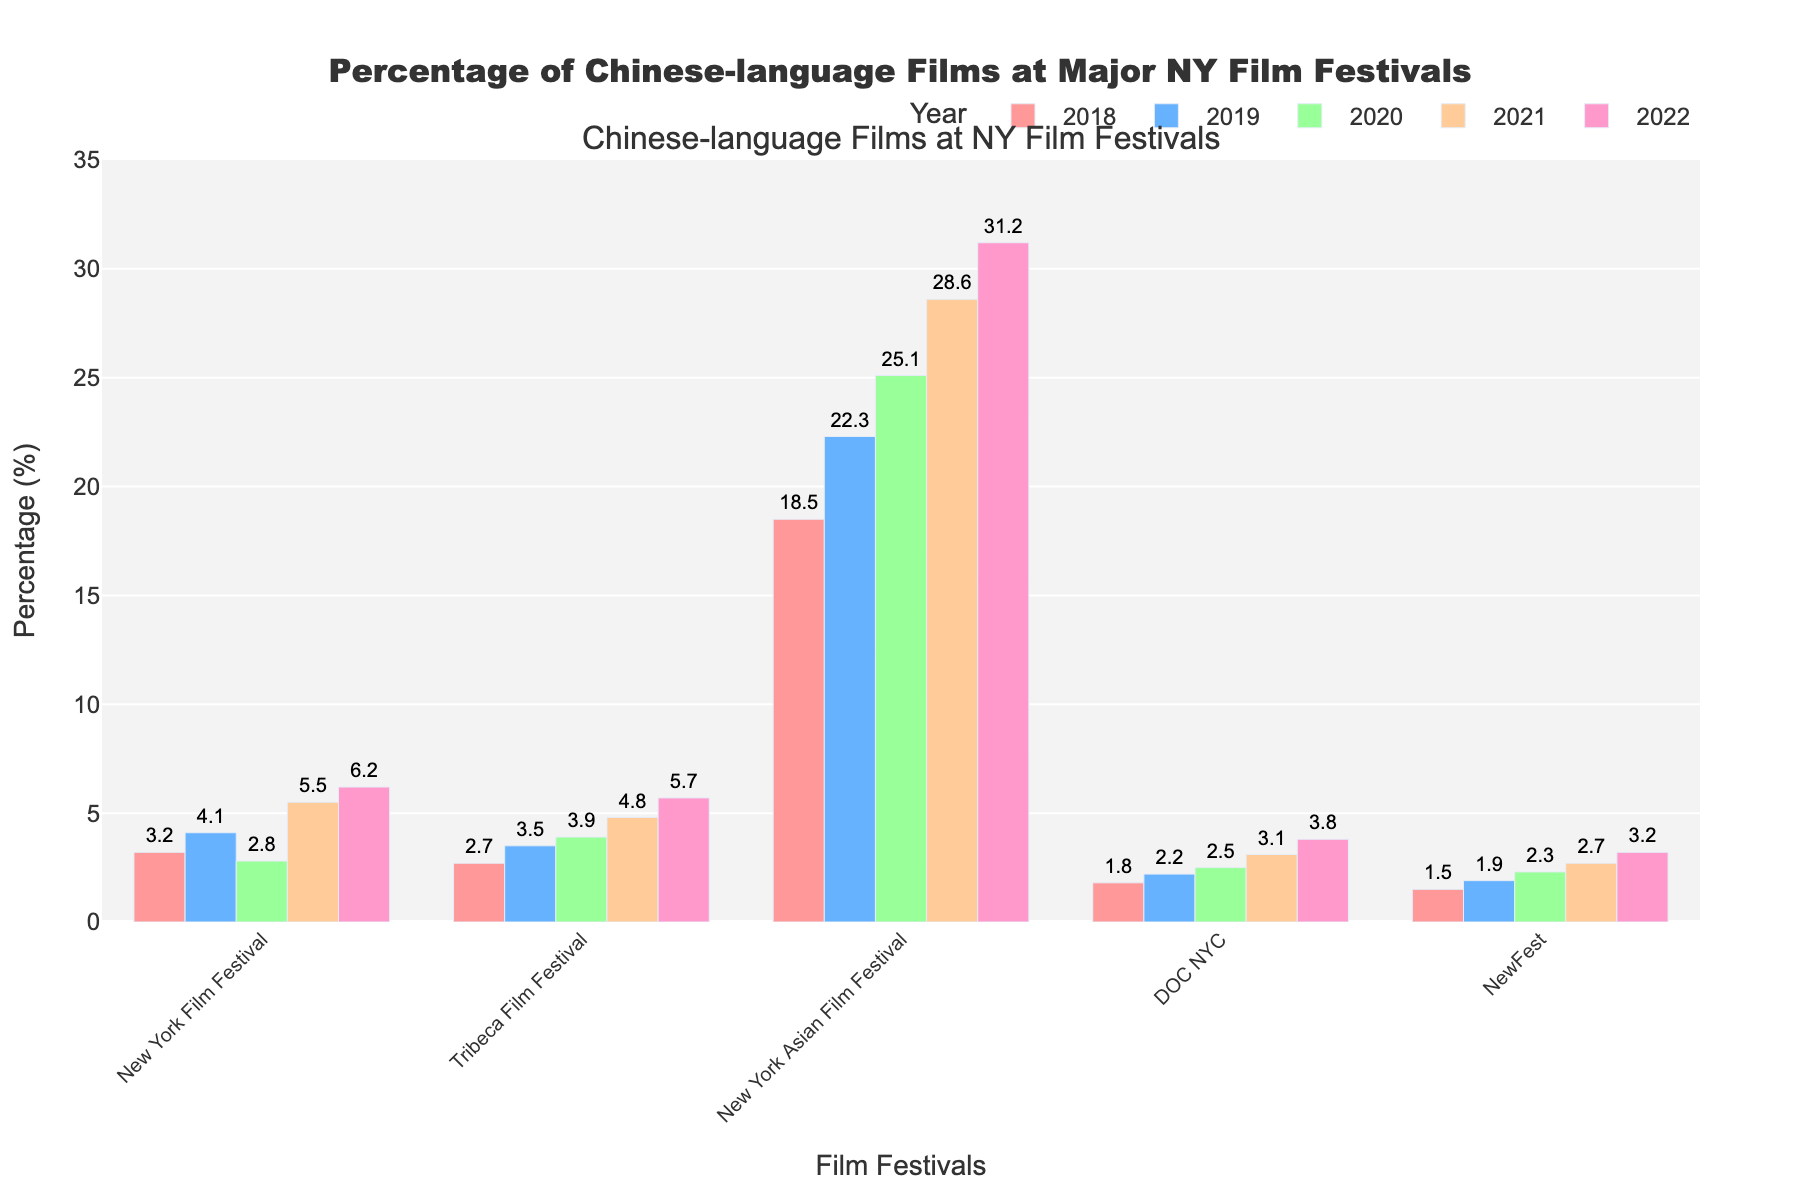Which festival had the highest percentage of Chinese-language films in 2022? The data shows the percentage of Chinese-language films for each festival in 2022. By comparing these percentages, we can identify that the New York Asian Film Festival had the highest percentage.
Answer: New York Asian Film Festival Which festival showed the lowest increase in percentage of Chinese-language films from 2018 to 2022? To answer this, we need to calculate the percentage increase for each festival from 2018 to 2022 and compare them. The calculations are: 
New York Film Festival: 6.2 - 3.2 = 3.0 
Tribeca Film Festival: 5.7 - 2.7 = 3.0 
New York Asian Film Festival: 31.2 - 18.5 = 12.7 
DOC NYC: 3.8 - 1.8 = 2.0 
NewFest: 3.2 - 1.5 = 1.7 
Thus, NewFest had the lowest increase in percentage.
Answer: NewFest By how many percentage points did the New York Asian Film Festival's percentage of Chinese-language films increase from 2019 to 2020? We find the percentages for the New York Asian Film Festival in 2019 and 2020 and subtract the former from the latter. The calculations are: 25.1 - 22.3 = 2.8 percentage points.
Answer: 2.8 percentage points What is the average percentage of Chinese-language films for the Tribeca Film Festival over the 5-year period? We sum up the percentages for the Tribeca Film Festival for each year and then divide by 5. The calculations are: (2.7 + 3.5 + 3.9 + 4.8 + 5.7) / 5 = 20.6 / 5 = 4.12
Answer: 4.12 Which festival consistently increased its percentage of Chinese-language films every year? We check each row in the dataset to confirm if the percentage of Chinese-language films increased every year. The New York Asian Film Festival consistently shows an increase in its percentages from 2018 to 2022.
Answer: New York Asian Film Festival How much higher was the percentage of Chinese-language films at the New York Film Festival in 2021 compared to 2018? We find the percentages for the New York Film Festival in 2021 and 2018 and subtract the latter from the former. The calculations are: 5.5 - 3.2 = 2.3 percentage points.
Answer: 2.3 percentage points What is the total percentage of Chinese-language films shown at DOC NYC and NewFest in 2020? We sum the percentages of Chinese-language films shown at DOC NYC and NewFest in 2020. The calculations are: 2.5 (DOC NYC) + 2.3 (NewFest) = 4.8 percent.
Answer: 4.8 percent Which year had the lowest overall percentage of Chinese-language films across all festivals? We average the percentages for each year across all festivals and find the lowest average. The calculations are: 
2018: (3.2 + 2.7 + 18.5 + 1.8 + 1.5) / 5 = 5.54 
2019: (4.1 + 3.5 + 22.3 + 2.2 + 1.9) / 5 = 6.8 
2020: (2.8 + 3.9 + 25.1 + 2.5 + 2.3) / 5 = 7.32 
2021: (5.5 + 4.8 + 28.6 + 3.1 + 2.7) / 5 = 8.94 
2022: (6.2 + 5.7 + 31.2 + 3.8 + 3.2) / 5 = 10.02 
Thus, 2018 had the lowest overall percentage average.
Answer: 2018 